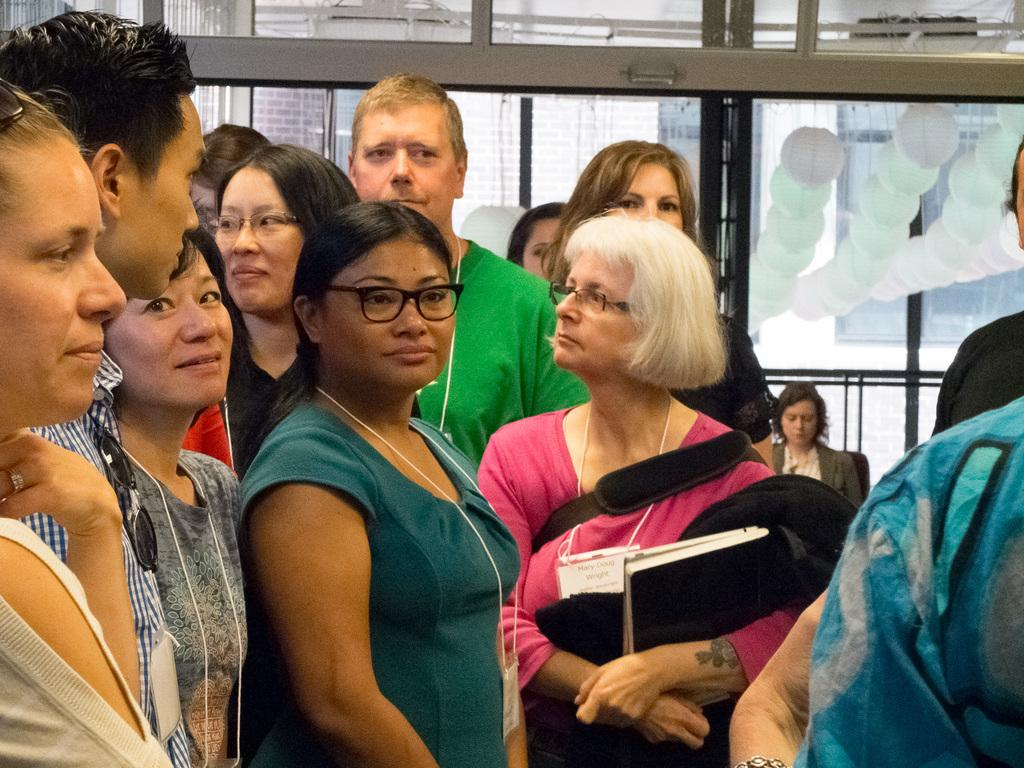What is happening in the image involving a group of people? There is a group of people standing in the image. What is the woman in the image doing? A woman is holding objects in the image. What can be seen in the background of the image? There is a framed glass wall and round-shaped objects in the background of the image. How many tails can be seen on the people in the image? There are no tails visible on the people in the image, as humans do not have tails. What type of land is visible in the image? There is no land visible in the image, as it appears to be an indoor setting with a framed glass wall in the background. 